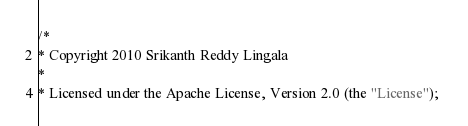Convert code to text. <code><loc_0><loc_0><loc_500><loc_500><_Java_>/*
* Copyright 2010 Srikanth Reddy Lingala  
* 
* Licensed under the Apache License, Version 2.0 (the "License"); </code> 